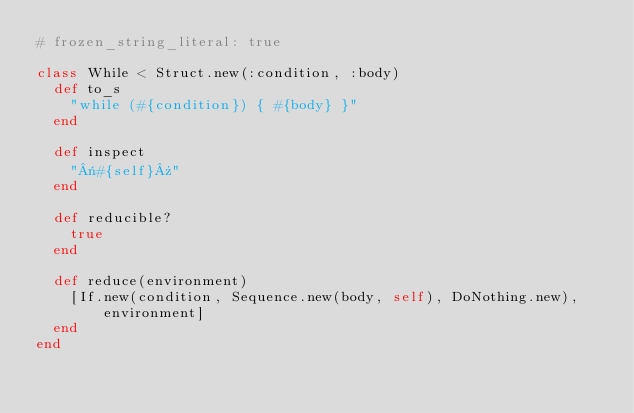<code> <loc_0><loc_0><loc_500><loc_500><_Ruby_># frozen_string_literal: true

class While < Struct.new(:condition, :body)
  def to_s
    "while (#{condition}) { #{body} }"
  end

  def inspect
    "«#{self}»"
  end

  def reducible?
    true
  end

  def reduce(environment)
    [If.new(condition, Sequence.new(body, self), DoNothing.new), environment]
  end
end
</code> 